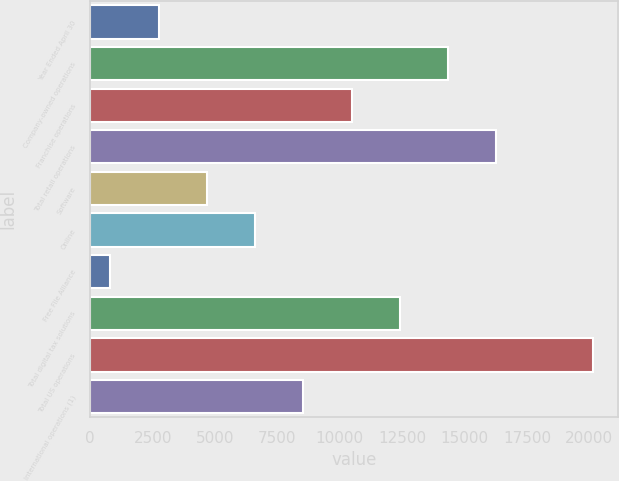<chart> <loc_0><loc_0><loc_500><loc_500><bar_chart><fcel>Year Ended April 30<fcel>Company-owned operations<fcel>Franchise operations<fcel>Total retail operations<fcel>Software<fcel>Online<fcel>Free File Alliance<fcel>Total digital tax solutions<fcel>Total US operations<fcel>International operations (1)<nl><fcel>2743.2<fcel>14342.4<fcel>10476<fcel>16275.6<fcel>4676.4<fcel>6609.6<fcel>810<fcel>12409.2<fcel>20142<fcel>8542.8<nl></chart> 